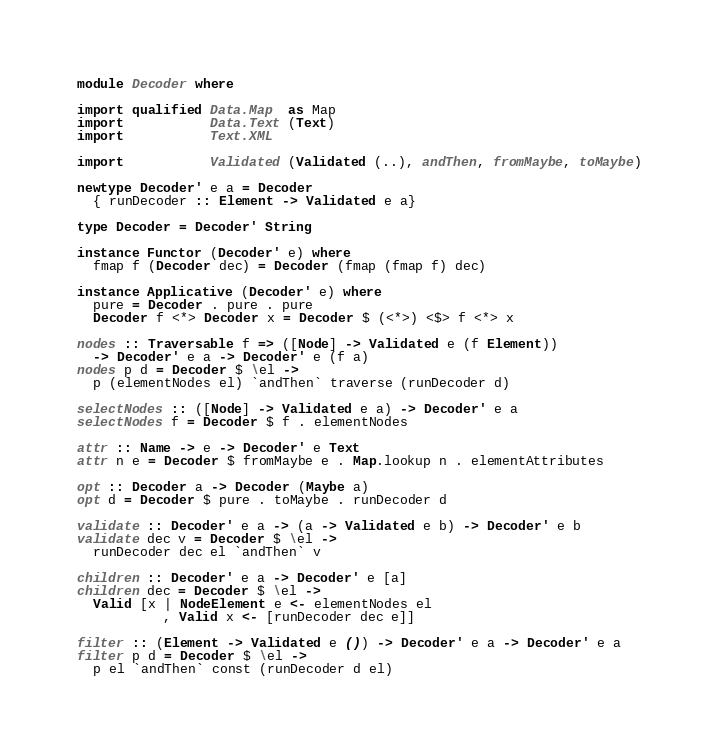Convert code to text. <code><loc_0><loc_0><loc_500><loc_500><_Haskell_>module Decoder where

import qualified Data.Map  as Map
import           Data.Text (Text)
import           Text.XML

import           Validated (Validated (..), andThen, fromMaybe, toMaybe)

newtype Decoder' e a = Decoder
  { runDecoder :: Element -> Validated e a}

type Decoder = Decoder' String

instance Functor (Decoder' e) where
  fmap f (Decoder dec) = Decoder (fmap (fmap f) dec)

instance Applicative (Decoder' e) where
  pure = Decoder . pure . pure
  Decoder f <*> Decoder x = Decoder $ (<*>) <$> f <*> x

nodes :: Traversable f => ([Node] -> Validated e (f Element))
  -> Decoder' e a -> Decoder' e (f a)
nodes p d = Decoder $ \el ->
  p (elementNodes el) `andThen` traverse (runDecoder d)

selectNodes :: ([Node] -> Validated e a) -> Decoder' e a
selectNodes f = Decoder $ f . elementNodes

attr :: Name -> e -> Decoder' e Text
attr n e = Decoder $ fromMaybe e . Map.lookup n . elementAttributes

opt :: Decoder a -> Decoder (Maybe a)
opt d = Decoder $ pure . toMaybe . runDecoder d

validate :: Decoder' e a -> (a -> Validated e b) -> Decoder' e b
validate dec v = Decoder $ \el ->
  runDecoder dec el `andThen` v

children :: Decoder' e a -> Decoder' e [a]
children dec = Decoder $ \el ->
  Valid [x | NodeElement e <- elementNodes el
           , Valid x <- [runDecoder dec e]]

filter :: (Element -> Validated e ()) -> Decoder' e a -> Decoder' e a
filter p d = Decoder $ \el ->
  p el `andThen` const (runDecoder d el)
</code> 